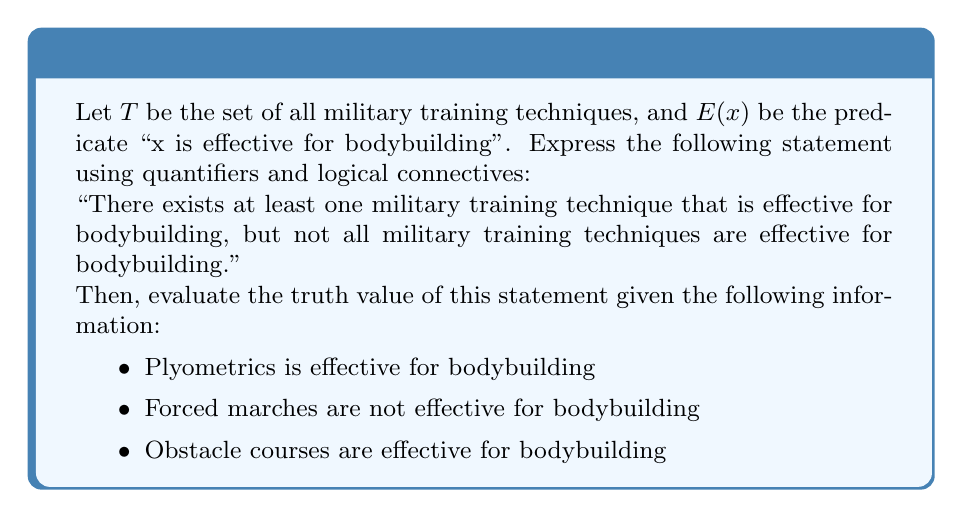What is the answer to this math problem? To express the given statement using quantifiers and logical connectives, we can break it down into two parts:

1. "There exists at least one military training technique that is effective for bodybuilding":
   $\exists x \in T (E(x))$

2. "Not all military training techniques are effective for bodybuilding":
   $\neg \forall x \in T (E(x))$

Combining these two parts with the logical AND connector, we get:

$$\exists x \in T (E(x)) \land \neg \forall x \in T (E(x))$$

Now, let's evaluate the truth value of this statement given the provided information:

1. $\exists x \in T (E(x))$:
   This part is true because we have two examples of effective techniques:
   - Plyometrics is effective for bodybuilding
   - Obstacle courses are effective for bodybuilding

2. $\neg \forall x \in T (E(x))$:
   This part is also true because we have an example of a technique that is not effective:
   - Forced marches are not effective for bodybuilding

Since both parts of the statement are true, and they are connected by the logical AND ($\land$), the entire statement is true.
Answer: The statement can be expressed as:
$$\exists x \in T (E(x)) \land \neg \forall x \in T (E(x))$$
Given the provided information, this statement is true. 